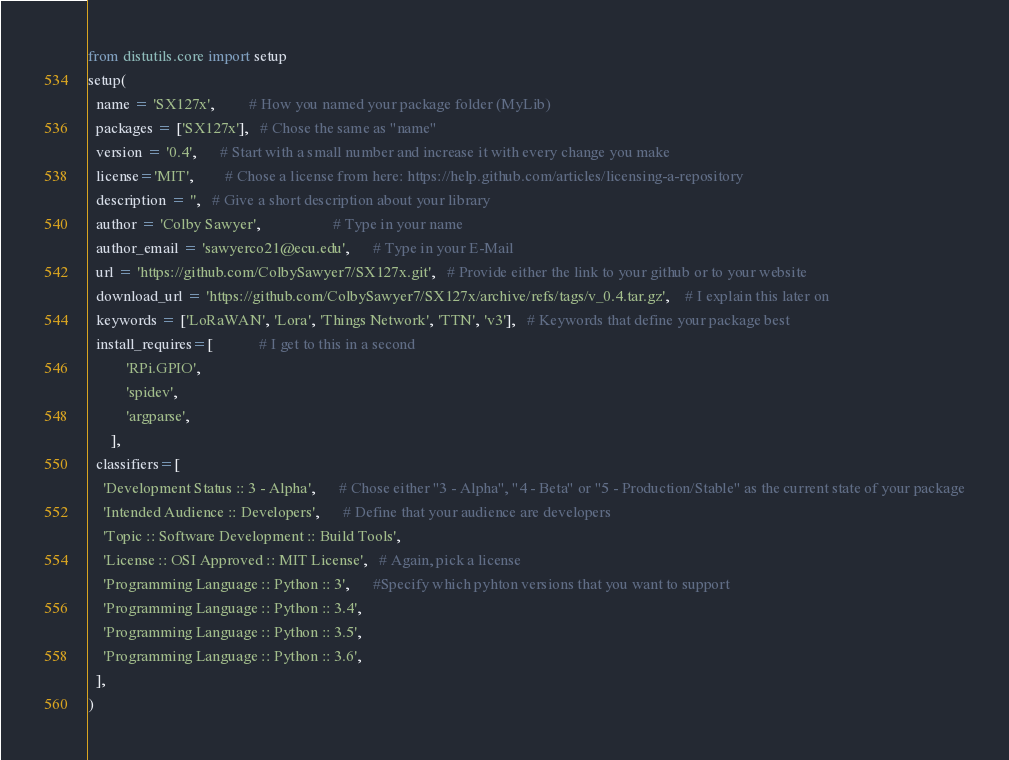Convert code to text. <code><loc_0><loc_0><loc_500><loc_500><_Python_>from distutils.core import setup
setup(
  name = 'SX127x',         # How you named your package folder (MyLib)
  packages = ['SX127x'],   # Chose the same as "name"
  version = '0.4',      # Start with a small number and increase it with every change you make
  license='MIT',        # Chose a license from here: https://help.github.com/articles/licensing-a-repository
  description = '',   # Give a short description about your library
  author = 'Colby Sawyer',                   # Type in your name
  author_email = 'sawyerco21@ecu.edu',      # Type in your E-Mail
  url = 'https://github.com/ColbySawyer7/SX127x.git',   # Provide either the link to your github or to your website
  download_url = 'https://github.com/ColbySawyer7/SX127x/archive/refs/tags/v_0.4.tar.gz',    # I explain this later on
  keywords = ['LoRaWAN', 'Lora', 'Things Network', 'TTN', 'v3'],   # Keywords that define your package best
  install_requires=[            # I get to this in a second
          'RPi.GPIO',
          'spidev',
          'argparse',
      ],
  classifiers=[
    'Development Status :: 3 - Alpha',      # Chose either "3 - Alpha", "4 - Beta" or "5 - Production/Stable" as the current state of your package
    'Intended Audience :: Developers',      # Define that your audience are developers
    'Topic :: Software Development :: Build Tools',
    'License :: OSI Approved :: MIT License',   # Again, pick a license
    'Programming Language :: Python :: 3',      #Specify which pyhton versions that you want to support
    'Programming Language :: Python :: 3.4',
    'Programming Language :: Python :: 3.5',
    'Programming Language :: Python :: 3.6',
  ],
)</code> 